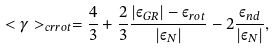Convert formula to latex. <formula><loc_0><loc_0><loc_500><loc_500>< \gamma > _ { c r r o t } = \frac { 4 } { 3 } + \frac { 2 } { 3 } \frac { | \varepsilon _ { G R } | - \varepsilon _ { r o t } } { | \varepsilon _ { N } | } - 2 \frac { \varepsilon _ { n d } } { | \varepsilon _ { N } | } ,</formula> 